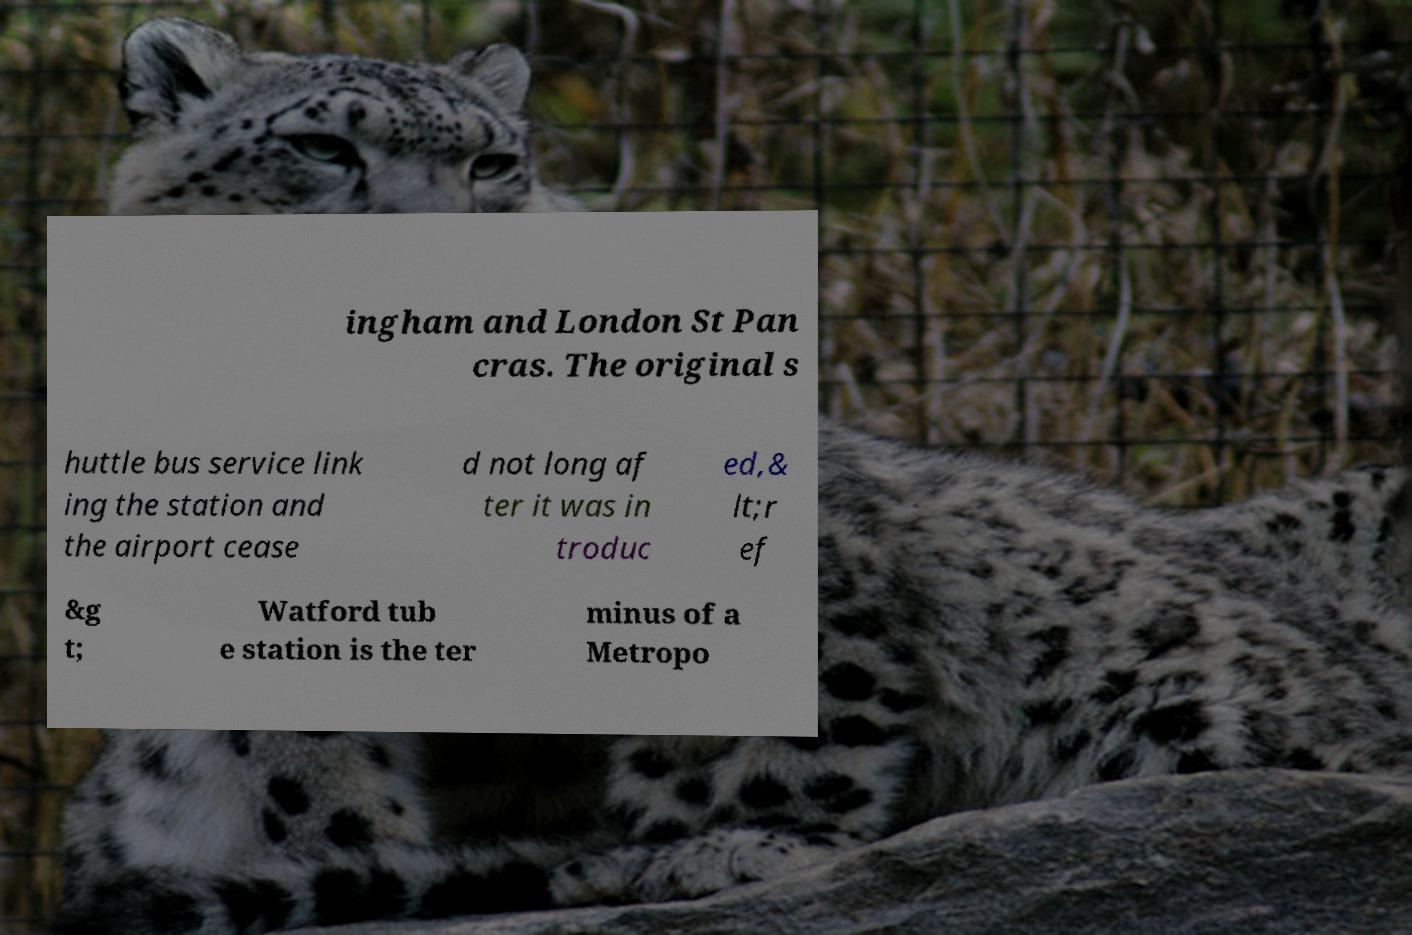Can you accurately transcribe the text from the provided image for me? ingham and London St Pan cras. The original s huttle bus service link ing the station and the airport cease d not long af ter it was in troduc ed,& lt;r ef &g t; Watford tub e station is the ter minus of a Metropo 